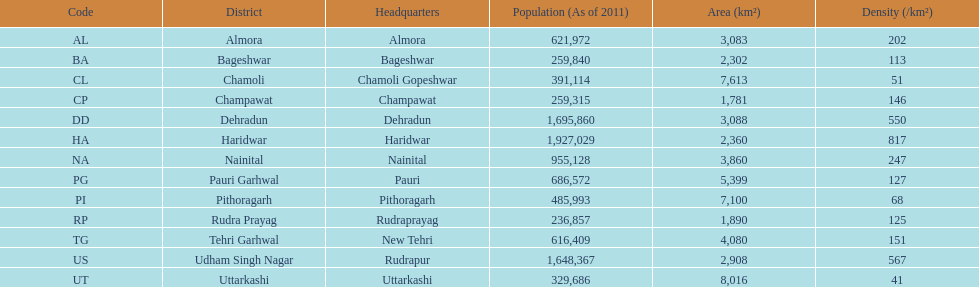Tell me a district that only has a density of 51. Chamoli. 